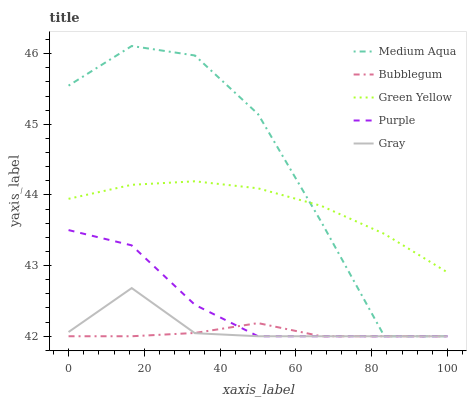Does Bubblegum have the minimum area under the curve?
Answer yes or no. Yes. Does Medium Aqua have the maximum area under the curve?
Answer yes or no. Yes. Does Gray have the minimum area under the curve?
Answer yes or no. No. Does Gray have the maximum area under the curve?
Answer yes or no. No. Is Bubblegum the smoothest?
Answer yes or no. Yes. Is Medium Aqua the roughest?
Answer yes or no. Yes. Is Gray the smoothest?
Answer yes or no. No. Is Gray the roughest?
Answer yes or no. No. Does Purple have the lowest value?
Answer yes or no. Yes. Does Green Yellow have the lowest value?
Answer yes or no. No. Does Medium Aqua have the highest value?
Answer yes or no. Yes. Does Gray have the highest value?
Answer yes or no. No. Is Bubblegum less than Green Yellow?
Answer yes or no. Yes. Is Green Yellow greater than Gray?
Answer yes or no. Yes. Does Purple intersect Bubblegum?
Answer yes or no. Yes. Is Purple less than Bubblegum?
Answer yes or no. No. Is Purple greater than Bubblegum?
Answer yes or no. No. Does Bubblegum intersect Green Yellow?
Answer yes or no. No. 